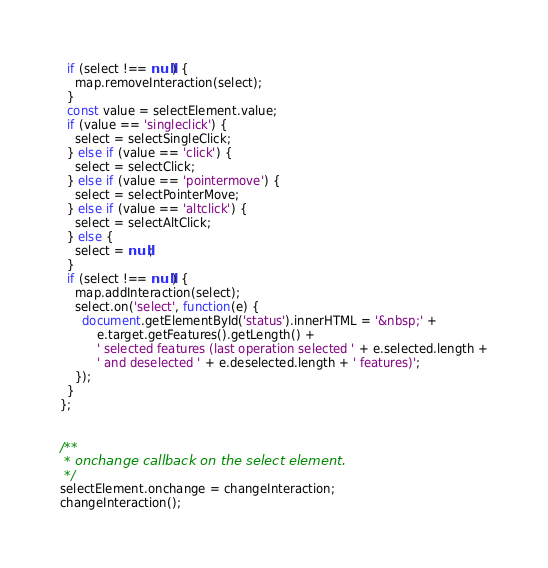Convert code to text. <code><loc_0><loc_0><loc_500><loc_500><_JavaScript_>  if (select !== null) {
    map.removeInteraction(select);
  }
  const value = selectElement.value;
  if (value == 'singleclick') {
    select = selectSingleClick;
  } else if (value == 'click') {
    select = selectClick;
  } else if (value == 'pointermove') {
    select = selectPointerMove;
  } else if (value == 'altclick') {
    select = selectAltClick;
  } else {
    select = null;
  }
  if (select !== null) {
    map.addInteraction(select);
    select.on('select', function(e) {
      document.getElementById('status').innerHTML = '&nbsp;' +
          e.target.getFeatures().getLength() +
          ' selected features (last operation selected ' + e.selected.length +
          ' and deselected ' + e.deselected.length + ' features)';
    });
  }
};


/**
 * onchange callback on the select element.
 */
selectElement.onchange = changeInteraction;
changeInteraction();
</code> 